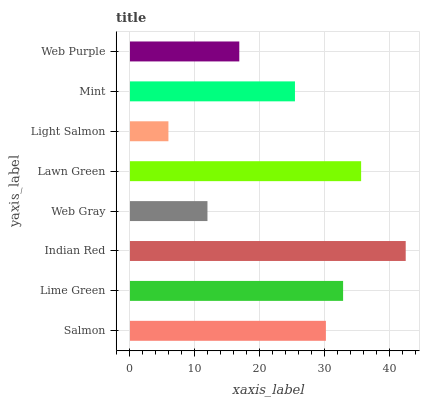Is Light Salmon the minimum?
Answer yes or no. Yes. Is Indian Red the maximum?
Answer yes or no. Yes. Is Lime Green the minimum?
Answer yes or no. No. Is Lime Green the maximum?
Answer yes or no. No. Is Lime Green greater than Salmon?
Answer yes or no. Yes. Is Salmon less than Lime Green?
Answer yes or no. Yes. Is Salmon greater than Lime Green?
Answer yes or no. No. Is Lime Green less than Salmon?
Answer yes or no. No. Is Salmon the high median?
Answer yes or no. Yes. Is Mint the low median?
Answer yes or no. Yes. Is Light Salmon the high median?
Answer yes or no. No. Is Salmon the low median?
Answer yes or no. No. 